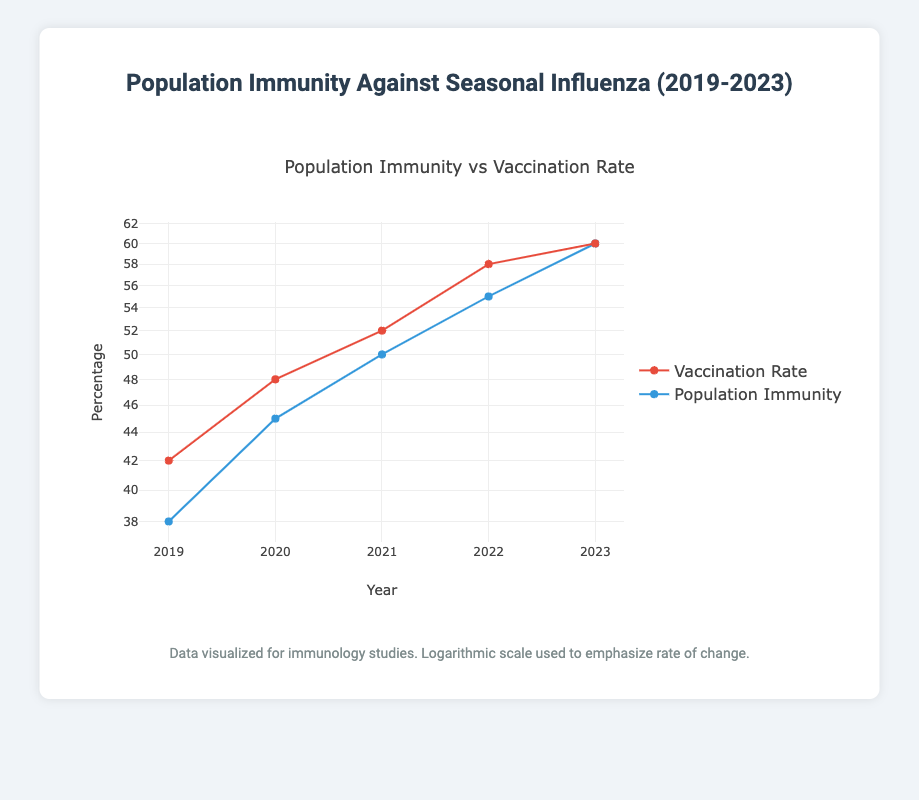What was the population immunity percentage in 2020? The specific value for the population immunity percentage in 2020 is given directly in the table as 45%.
Answer: 45% In which year did the vaccination rate first exceed 50%? By examining the vaccination rate percentages from the years provided, we see that it exceeds 50% for the first time in 2021, where the percentage is 52%.
Answer: 2021 What is the difference between the highest and lowest population immunity percentages over the 5 years? The highest population immunity percentage is 60% (in 2023) and the lowest is 38% (in 2019). The difference between these values is calculated as 60% - 38% = 22%.
Answer: 22% Did the population immunity percentage increase every year from 2019 to 2023? By checking each consecutive year's population immunity percentage, we see it increased from 38% (2019) to 60% (2023). Thus, the population immunity percentage indeed increased each year.
Answer: Yes What was the average vaccination rate percentage over the five years? The vaccination rates for the five years are 42%, 48%, 52%, 58%, and 60%. Summing these gives 42 + 48 + 52 + 58 + 60 = 260. Dividing by 5 (the number of years) results in an average of 260 / 5 = 52%.
Answer: 52% What year had the largest absolute increase in population immunity percentage compared to the previous year? The increases are: 2020: 45 - 38 = 7%, 2021: 50 - 45 = 5%, 2022: 55 - 50 = 5%, and 2023: 60 - 55 = 5%. The largest increase of 7% occurs from 2019 to 2020.
Answer: 2019 to 2020 Is the vaccination rate percentage higher than the population immunity percentage in 2023? The vaccination rate percentage in 2023 is 60%, which equals the population immunity percentage of 60%. They are not higher, indicating they are equal.
Answer: No What was the trend in population immunity percentage from 2019 to 2023? By examining the values year on year, we see an upward trend: 38% (2019), 45% (2020), 50% (2021), 55% (2022), and 60% (2023). The trend indicates consistent growth in population immunity.
Answer: Upward trend 